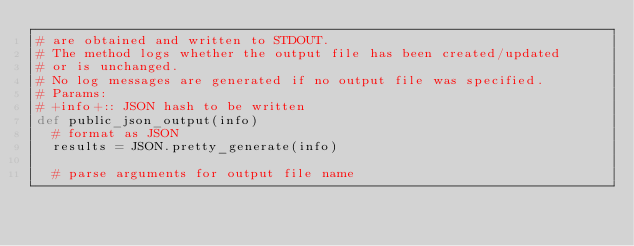Convert code to text. <code><loc_0><loc_0><loc_500><loc_500><_Ruby_># are obtained and written to STDOUT.
# The method logs whether the output file has been created/updated
# or is unchanged.
# No log messages are generated if no output file was specified.
# Params:
# +info+:: JSON hash to be written
def public_json_output(info)
  # format as JSON
  results = JSON.pretty_generate(info)

  # parse arguments for output file name</code> 